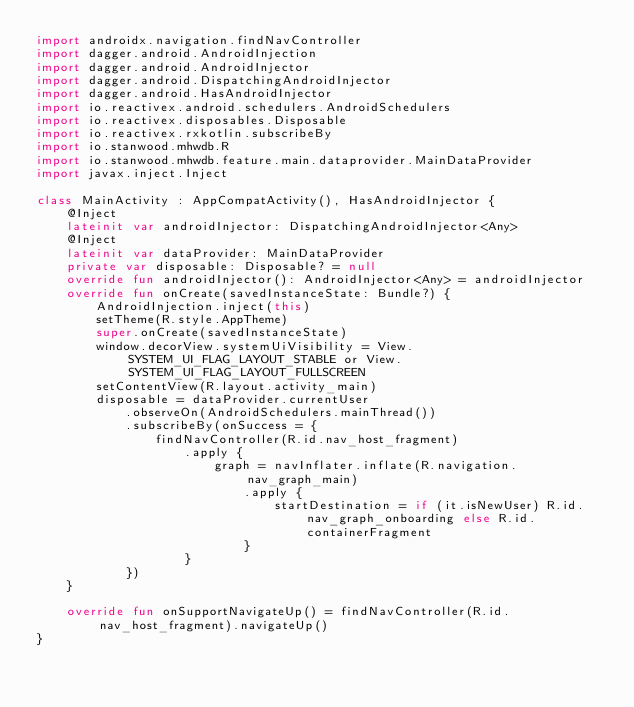<code> <loc_0><loc_0><loc_500><loc_500><_Kotlin_>import androidx.navigation.findNavController
import dagger.android.AndroidInjection
import dagger.android.AndroidInjector
import dagger.android.DispatchingAndroidInjector
import dagger.android.HasAndroidInjector
import io.reactivex.android.schedulers.AndroidSchedulers
import io.reactivex.disposables.Disposable
import io.reactivex.rxkotlin.subscribeBy
import io.stanwood.mhwdb.R
import io.stanwood.mhwdb.feature.main.dataprovider.MainDataProvider
import javax.inject.Inject

class MainActivity : AppCompatActivity(), HasAndroidInjector {
    @Inject
    lateinit var androidInjector: DispatchingAndroidInjector<Any>
    @Inject
    lateinit var dataProvider: MainDataProvider
    private var disposable: Disposable? = null
    override fun androidInjector(): AndroidInjector<Any> = androidInjector
    override fun onCreate(savedInstanceState: Bundle?) {
        AndroidInjection.inject(this)
        setTheme(R.style.AppTheme)
        super.onCreate(savedInstanceState)
        window.decorView.systemUiVisibility = View.SYSTEM_UI_FLAG_LAYOUT_STABLE or View.SYSTEM_UI_FLAG_LAYOUT_FULLSCREEN
        setContentView(R.layout.activity_main)
        disposable = dataProvider.currentUser
            .observeOn(AndroidSchedulers.mainThread())
            .subscribeBy(onSuccess = {
                findNavController(R.id.nav_host_fragment)
                    .apply {
                        graph = navInflater.inflate(R.navigation.nav_graph_main)
                            .apply {
                                startDestination = if (it.isNewUser) R.id.nav_graph_onboarding else R.id.containerFragment
                            }
                    }
            })
    }

    override fun onSupportNavigateUp() = findNavController(R.id.nav_host_fragment).navigateUp()
}</code> 